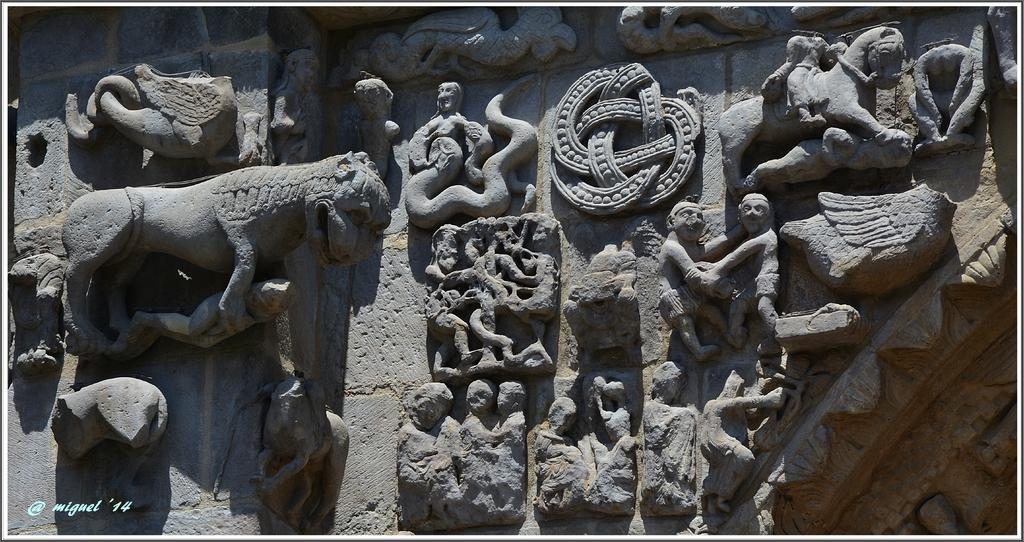What type of structure can be seen in the image? There is a stone wall in the image. What is depicted on the stone wall? Sculptures of people are present on the wall. What else can be seen in the sculptures besides the people? There are various other objects depicted in the sculptures. Where is the text located in the image? The text is visible at the bottom left of the image. What type of animal can be seen crawling out of the worm in the image? There is no animal or worm present in the image; it features a stone wall with sculptures of people. 